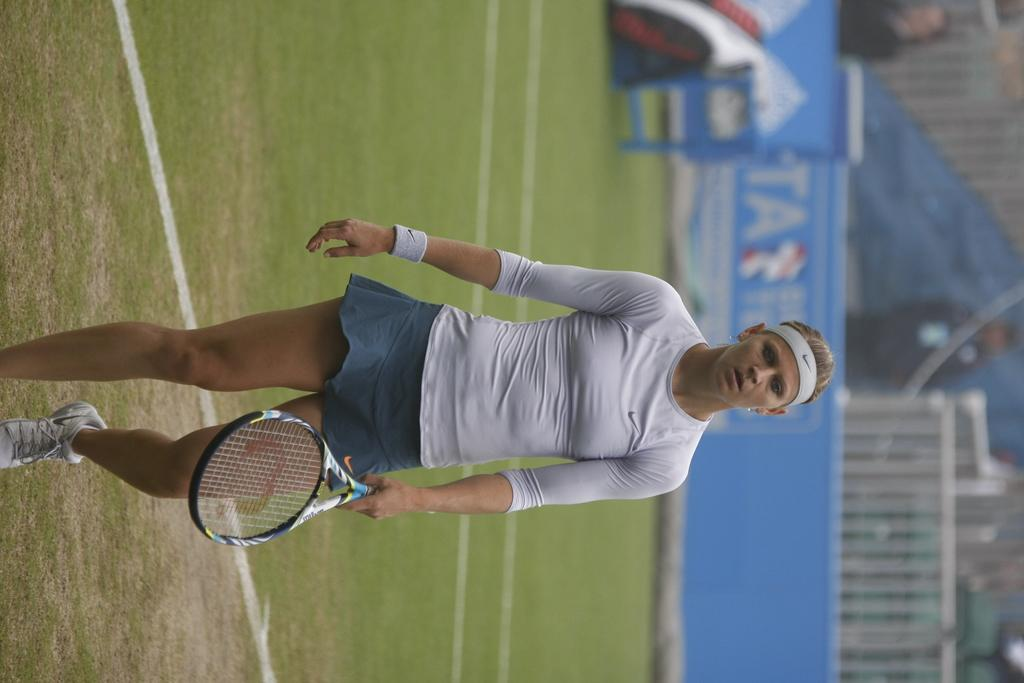Who or what is present in the image? There is a person in the image. What is the person holding in the image? The person is holding a tennis bat. What type of surface is visible in the image? There is grass visible in the image. What can be seen on the board in the background? There is a written text on a board in the background. What architectural feature is present in the background? There is fencing in the background. How many objects can be identified in the image? There are a few objects in the image. What type of marble is visible in the image? There is no marble present in the image. 